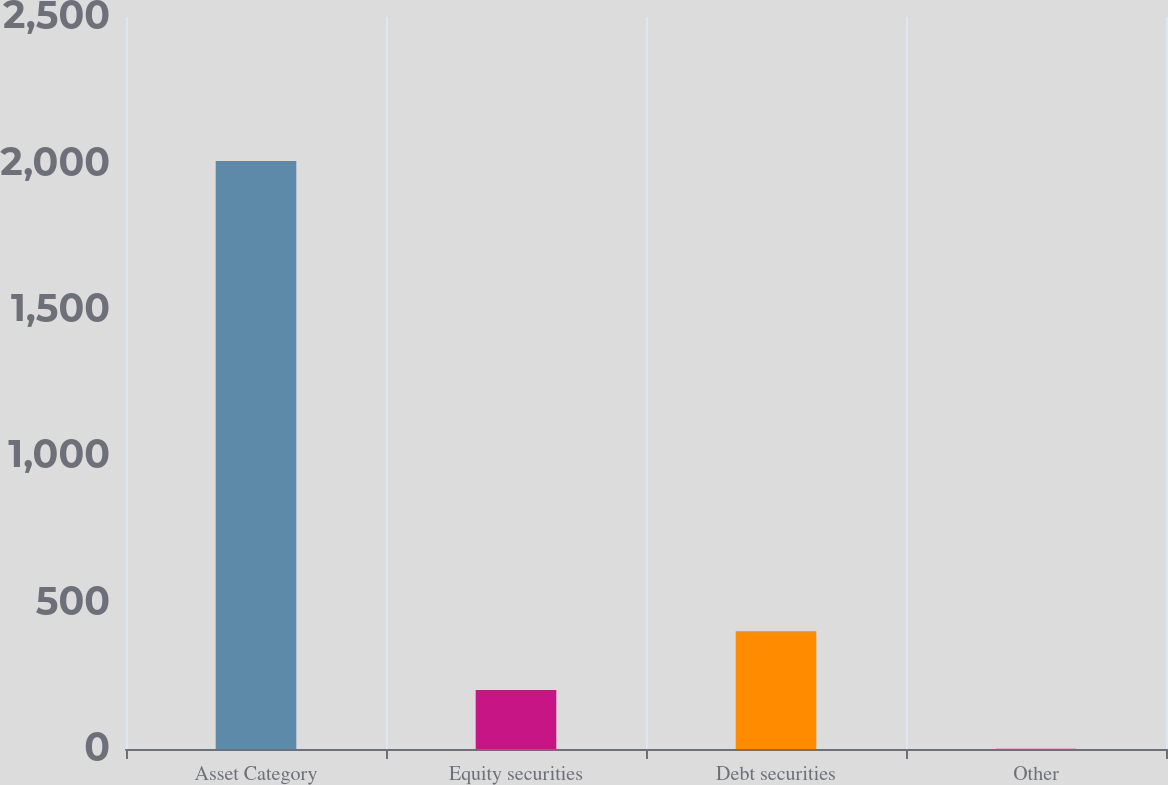<chart> <loc_0><loc_0><loc_500><loc_500><bar_chart><fcel>Asset Category<fcel>Equity securities<fcel>Debt securities<fcel>Other<nl><fcel>2008<fcel>201.7<fcel>402.4<fcel>1<nl></chart> 